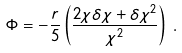<formula> <loc_0><loc_0><loc_500><loc_500>\Phi = - \frac { r } { 5 } \left ( \frac { 2 \chi \delta \chi + \delta \chi ^ { 2 } } { \chi ^ { 2 } } \right ) \, .</formula> 